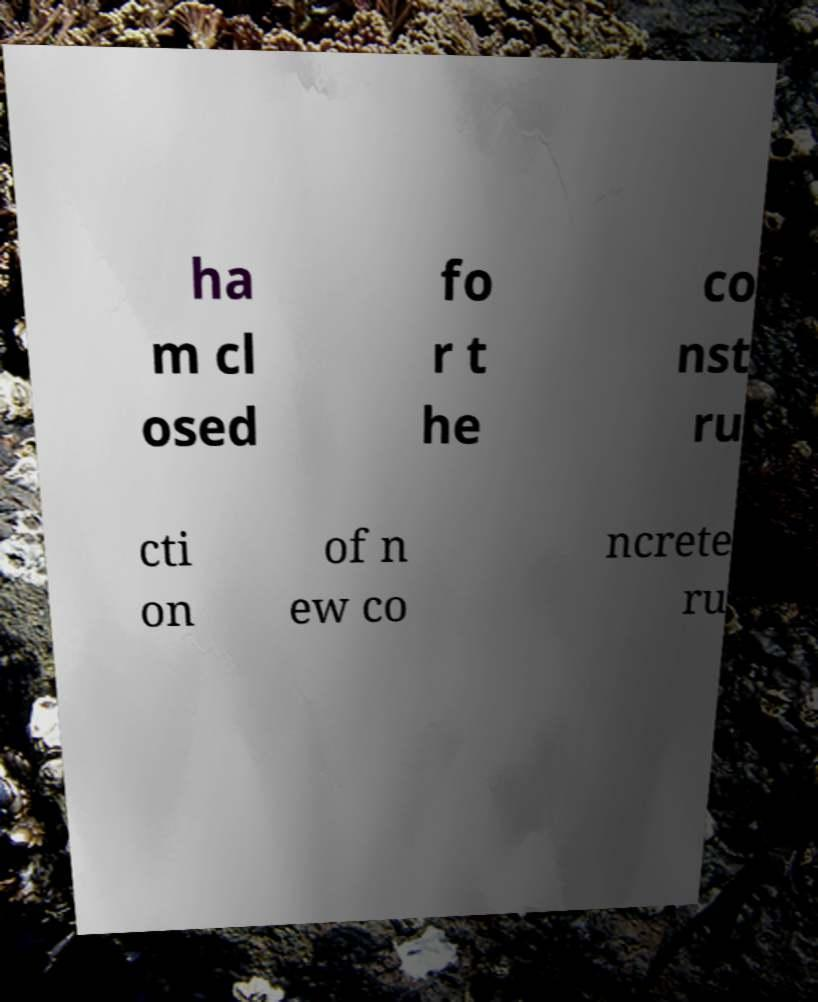Can you accurately transcribe the text from the provided image for me? ha m cl osed fo r t he co nst ru cti on of n ew co ncrete ru 